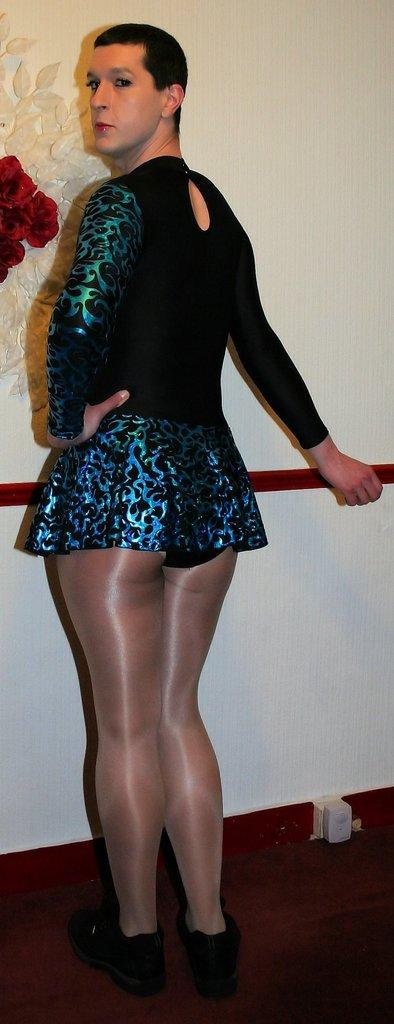What is the person in the image wearing? The person is wearing a dress with black, green, and blue colors. What can be seen on the left side of the image? There are red color flowers on the left side of the image. What is visible in the background of the image? There is a wall visible in the background of the image. Can you tell me how many airplanes are flying in the image? There are no airplanes visible in the image. Is the person in the image folding their dress? The image does not show the person folding their dress. 